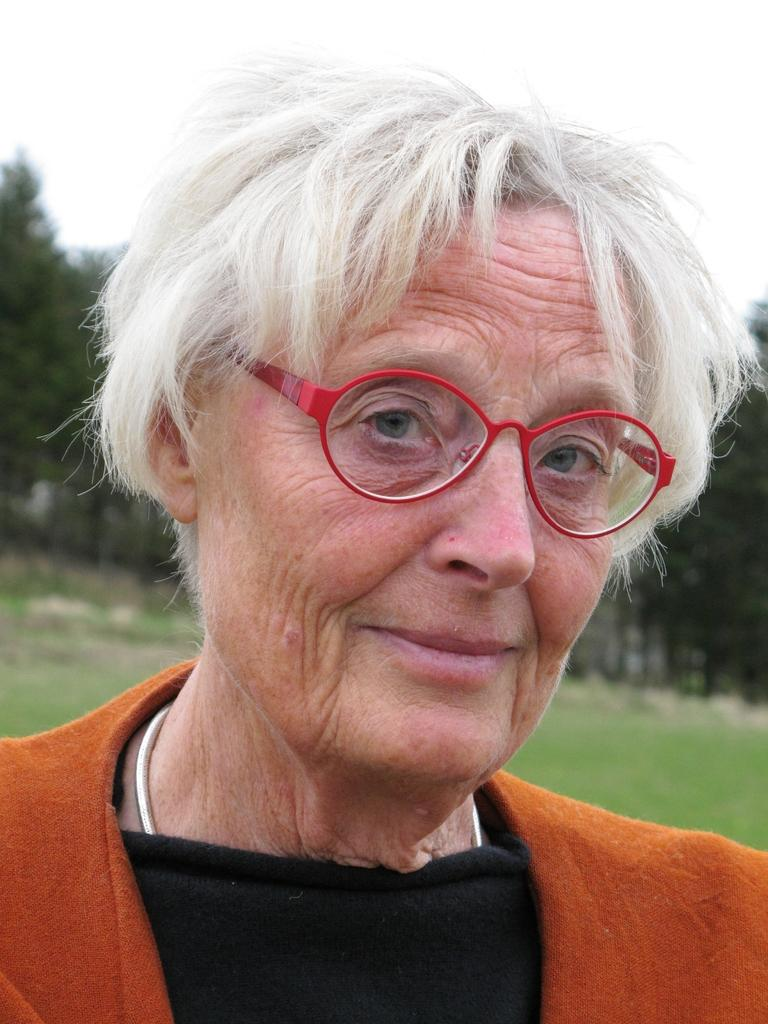Who is present in the image? There is a woman in the image. What is the woman's facial expression? The woman is smiling. What accessory is the woman wearing? The woman is wearing spectacles. What can be seen in the background of the image? There is grass and trees in the background of the image. What type of engine is visible in the image? There is no engine present in the image; it features a woman smiling and wearing spectacles, with grass and trees in the background. 